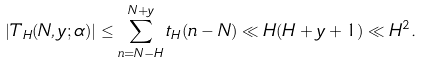<formula> <loc_0><loc_0><loc_500><loc_500>| T _ { H } ( N , y ; \alpha ) | \leq \sum _ { n = N - H } ^ { N + y } t _ { H } ( n - N ) \ll H ( H + y + 1 ) \ll H ^ { 2 } .</formula> 